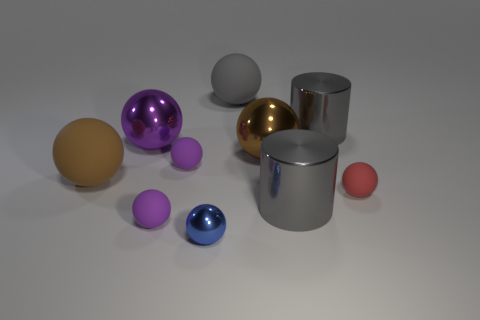Is the number of big brown spheres that are to the right of the brown rubber ball less than the number of small red rubber objects?
Your answer should be very brief. No. What color is the tiny thing that is behind the small red thing?
Keep it short and to the point. Purple. What shape is the red matte thing?
Provide a short and direct response. Sphere. Are there any large metal cylinders behind the gray metal thing that is on the right side of the big gray metallic thing in front of the brown rubber thing?
Provide a succinct answer. No. There is a cylinder behind the large rubber object in front of the shiny cylinder behind the small red thing; what is its color?
Offer a terse response. Gray. There is a red object that is the same shape as the brown metal thing; what is it made of?
Offer a very short reply. Rubber. There is a purple object in front of the purple matte thing that is behind the small red matte object; how big is it?
Keep it short and to the point. Small. There is a gray cylinder that is behind the red matte ball; what is its material?
Make the answer very short. Metal. What is the size of the red ball that is the same material as the big gray sphere?
Keep it short and to the point. Small. How many metal things are the same shape as the red matte object?
Provide a succinct answer. 3. 